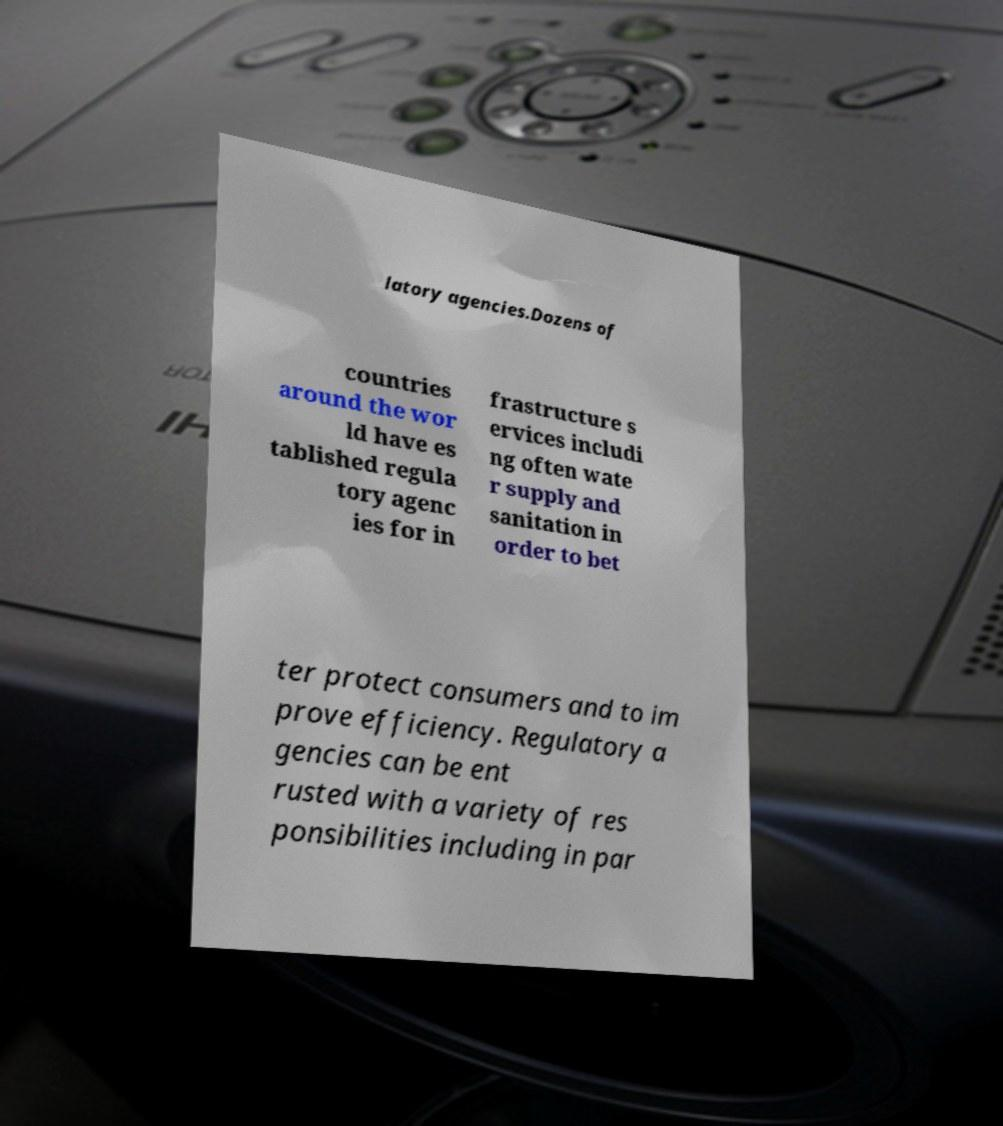Please identify and transcribe the text found in this image. latory agencies.Dozens of countries around the wor ld have es tablished regula tory agenc ies for in frastructure s ervices includi ng often wate r supply and sanitation in order to bet ter protect consumers and to im prove efficiency. Regulatory a gencies can be ent rusted with a variety of res ponsibilities including in par 